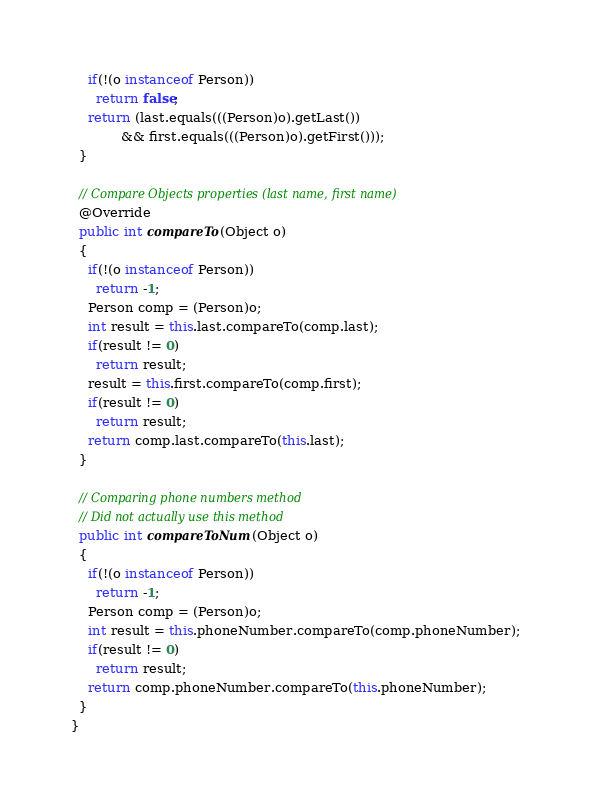Convert code to text. <code><loc_0><loc_0><loc_500><loc_500><_Java_>    if(!(o instanceof Person))
      return false;
    return (last.equals(((Person)o).getLast()) 
            && first.equals(((Person)o).getFirst()));
  }
  
  // Compare Objects properties (last name, first name)
  @Override
  public int compareTo(Object o)
  {
    if(!(o instanceof Person))
      return -1; 
    Person comp = (Person)o;
    int result = this.last.compareTo(comp.last);
    if(result != 0)
      return result;
    result = this.first.compareTo(comp.first);
    if(result != 0)
      return result; 
    return comp.last.compareTo(this.last);
  }
  
  // Comparing phone numbers method
  // Did not actually use this method
  public int compareToNum(Object o)
  {
    if(!(o instanceof Person))
      return -1; 
    Person comp = (Person)o;
    int result = this.phoneNumber.compareTo(comp.phoneNumber);
    if(result != 0)
      return result;
    return comp.phoneNumber.compareTo(this.phoneNumber);
  }
}</code> 